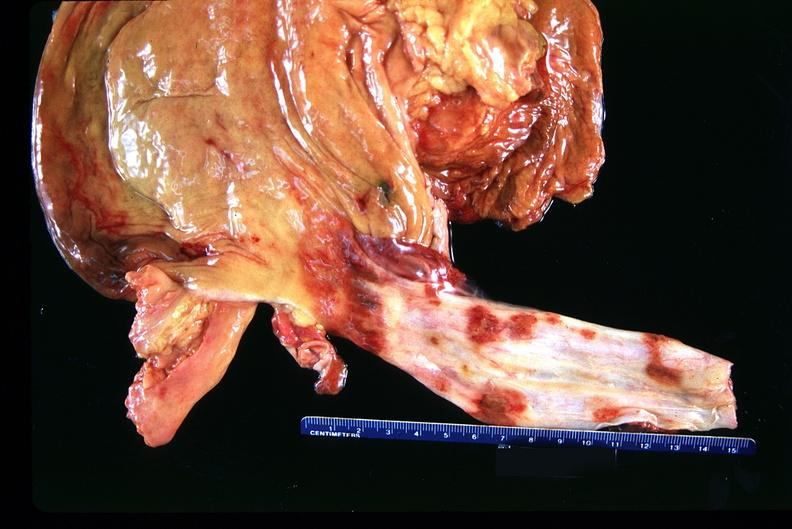s close-up excellent example of interosseous muscle atrophy present?
Answer the question using a single word or phrase. No 